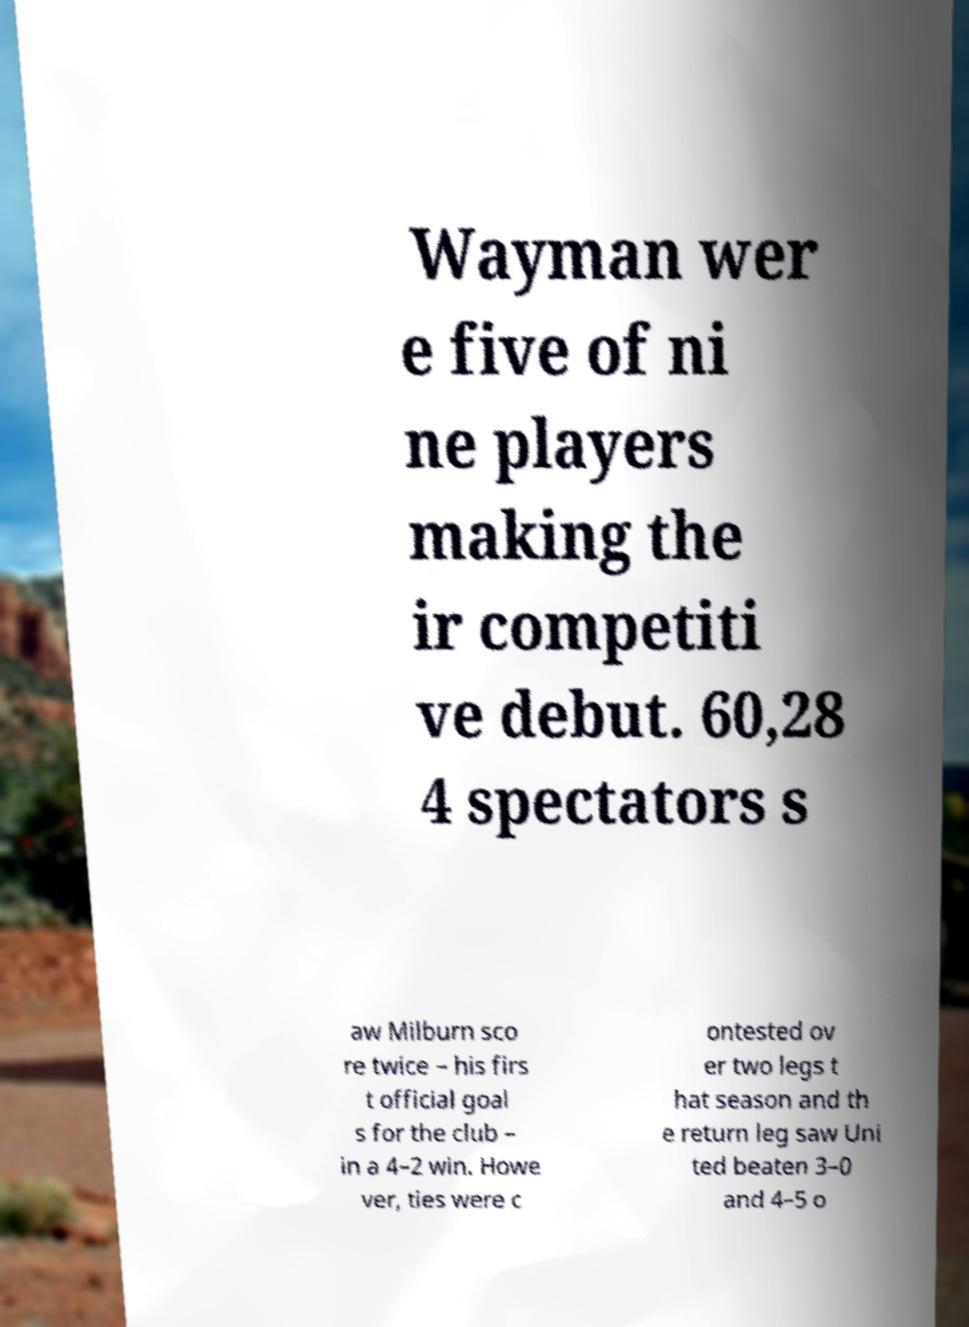For documentation purposes, I need the text within this image transcribed. Could you provide that? Wayman wer e five of ni ne players making the ir competiti ve debut. 60,28 4 spectators s aw Milburn sco re twice – his firs t official goal s for the club – in a 4–2 win. Howe ver, ties were c ontested ov er two legs t hat season and th e return leg saw Uni ted beaten 3–0 and 4–5 o 